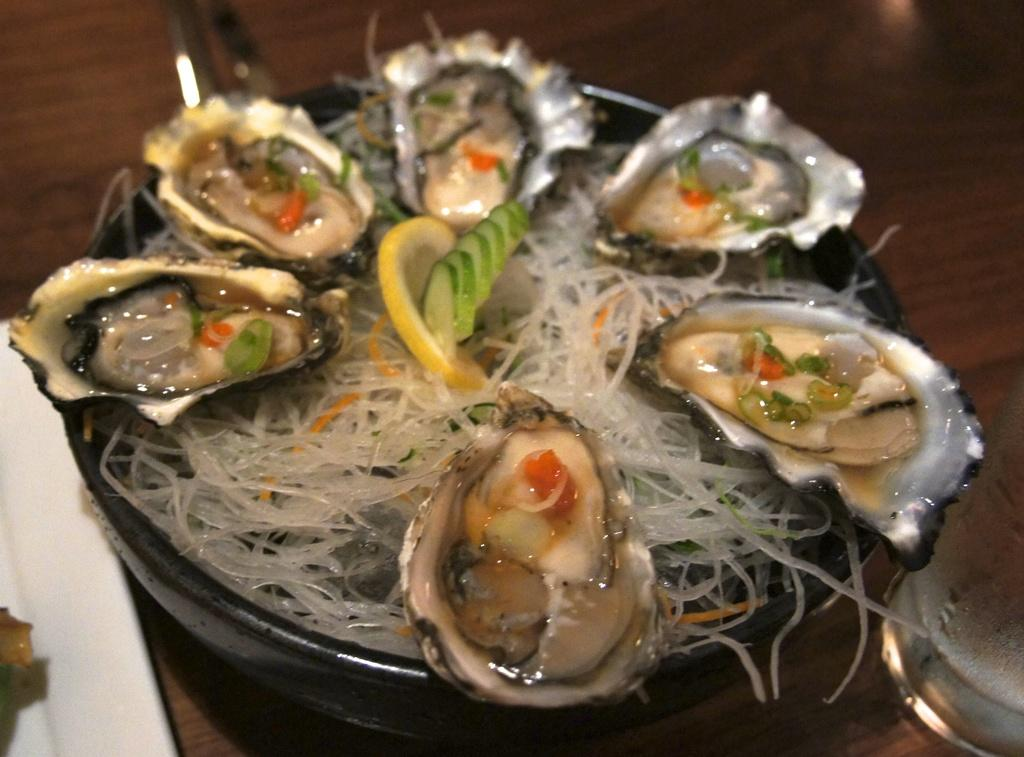What is present on the plate in the image? There is food in a plate in the image. What chance does the letter have of being eaten with the food in the image? There is no letter present in the image, so it cannot be eaten with the food. 